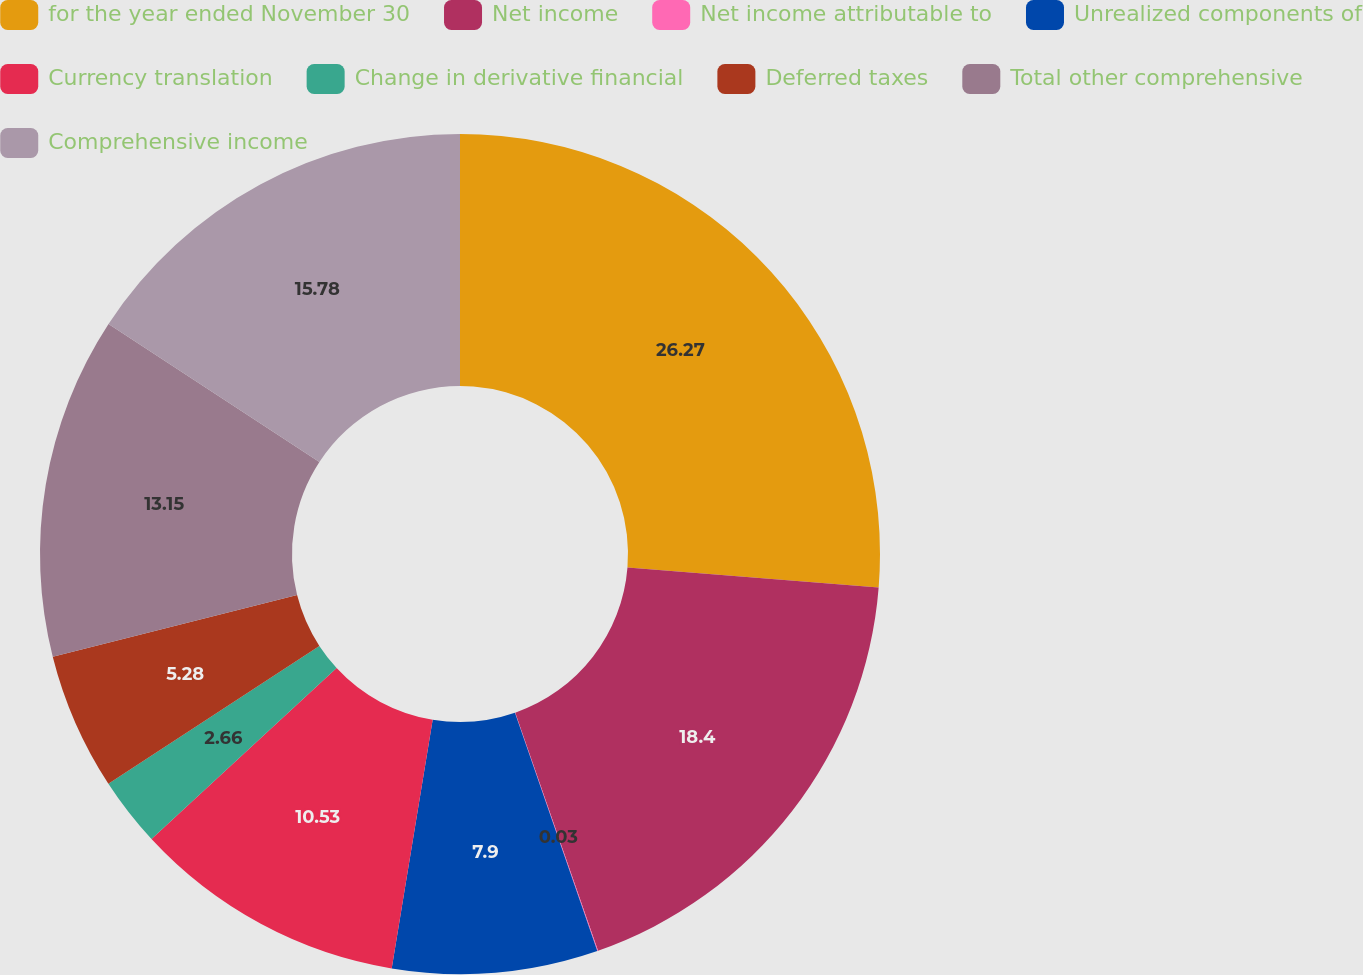Convert chart. <chart><loc_0><loc_0><loc_500><loc_500><pie_chart><fcel>for the year ended November 30<fcel>Net income<fcel>Net income attributable to<fcel>Unrealized components of<fcel>Currency translation<fcel>Change in derivative financial<fcel>Deferred taxes<fcel>Total other comprehensive<fcel>Comprehensive income<nl><fcel>26.27%<fcel>18.4%<fcel>0.03%<fcel>7.9%<fcel>10.53%<fcel>2.66%<fcel>5.28%<fcel>13.15%<fcel>15.78%<nl></chart> 